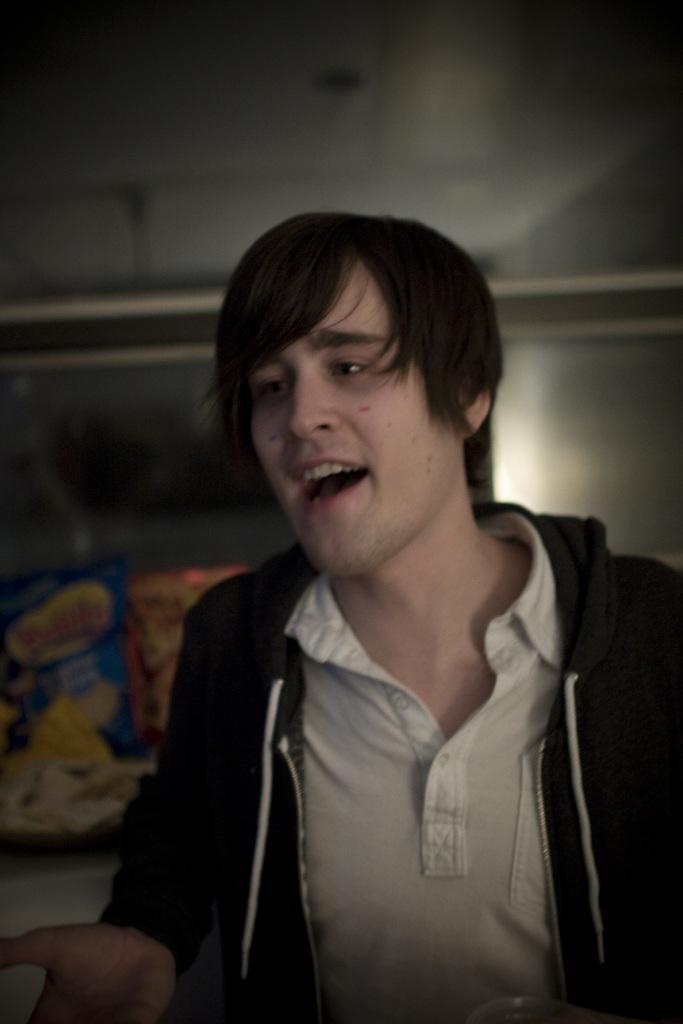In one or two sentences, can you explain what this image depicts? In this image, we can see a man, he is wearing a jacket, the background is not clear. 